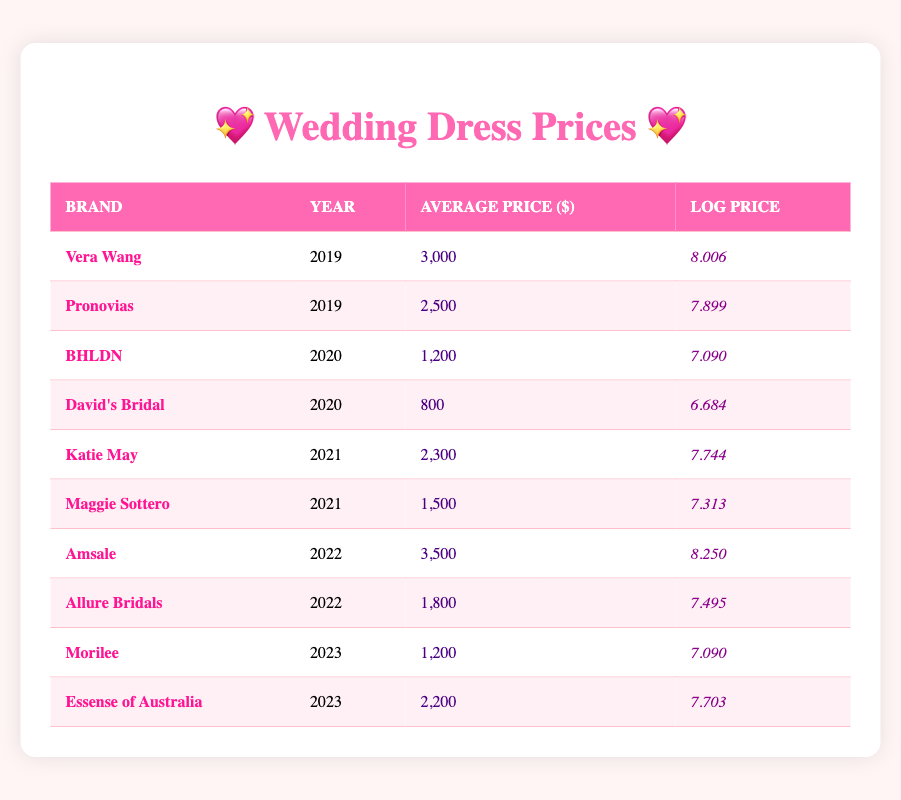What is the average price of Vera Wang wedding dresses in 2019? From the table, the average price of Vera Wang wedding dresses for the year 2019 is listed as 3000 dollars.
Answer: 3000 How much did the prices of David's Bridal change from 2020 to 2023? David's Bridal price in 2020 is 800 dollars and the data does not indicate a price for 2023. Therefore, we cannot calculate the change in price for that year.
Answer: Not applicable Which brand had the highest average price in 2022? In 2022, Amsale had the highest average price at 3500 dollars compared to Allure Bridals, which was 1800 dollars.
Answer: Amsale What is the difference in log prices between Katie May in 2021 and BHLDN in 2020? The log price of Katie May in 2021 is 7.744, and the log price of BHLDN in 2020 is 7.090. The difference is 7.744 - 7.090 = 0.654.
Answer: 0.654 Did Pronovias have a lower average price than Maggie Sottero in their respective years? Pronovias average price in 2019 is 2500 dollars, while Maggie Sottero in 2021 is 1500 dollars. Since 2500 is greater than 1500, the statement is false.
Answer: No What is the total average price of dresses from the brands listed for the year 2022? The average prices for 2022 are Amsale at 3500 dollars and Allure Bridals at 1800 dollars. Their total is 3500 + 1800 = 5300, so the average for these two brands in 2022 is 5300 / 2 = 2650.
Answer: 2650 Which year had the lowest average price among the brands listed? The lowest average price is 800 dollars for David's Bridal in 2020. This is checked against all the prices in the table.
Answer: 2020 Is the average price of Essense of Australia higher than the average price of BHLDN? Essense of Australia's average price in 2023 is 2200 dollars, and BHLDN’s average price in 2020 is 1200 dollars; since 2200 is greater than 1200, the statement is true.
Answer: Yes What was the overall trend in average prices from 2019 to 2022? The average prices indicate a rise. Vera Wang in 2019 was 3000 dollars, rising to Amsale's 3500 dollars by 2022. The trend shows increasing wedding dress prices over these years.
Answer: Increasing trend 